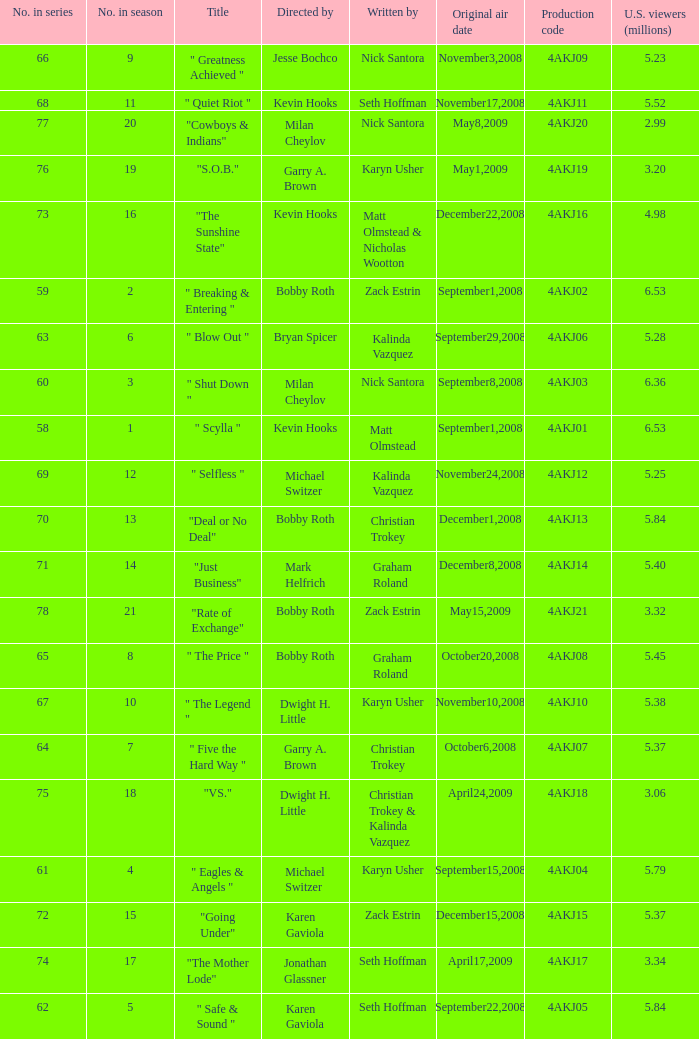Who directed the episode with production code 4akj01? Kevin Hooks. Could you help me parse every detail presented in this table? {'header': ['No. in series', 'No. in season', 'Title', 'Directed by', 'Written by', 'Original air date', 'Production code', 'U.S. viewers (millions)'], 'rows': [['66', '9', '" Greatness Achieved "', 'Jesse Bochco', 'Nick Santora', 'November3,2008', '4AKJ09', '5.23'], ['68', '11', '" Quiet Riot "', 'Kevin Hooks', 'Seth Hoffman', 'November17,2008', '4AKJ11', '5.52'], ['77', '20', '"Cowboys & Indians"', 'Milan Cheylov', 'Nick Santora', 'May8,2009', '4AKJ20', '2.99'], ['76', '19', '"S.O.B."', 'Garry A. Brown', 'Karyn Usher', 'May1,2009', '4AKJ19', '3.20'], ['73', '16', '"The Sunshine State"', 'Kevin Hooks', 'Matt Olmstead & Nicholas Wootton', 'December22,2008', '4AKJ16', '4.98'], ['59', '2', '" Breaking & Entering "', 'Bobby Roth', 'Zack Estrin', 'September1,2008', '4AKJ02', '6.53'], ['63', '6', '" Blow Out "', 'Bryan Spicer', 'Kalinda Vazquez', 'September29,2008', '4AKJ06', '5.28'], ['60', '3', '" Shut Down "', 'Milan Cheylov', 'Nick Santora', 'September8,2008', '4AKJ03', '6.36'], ['58', '1', '" Scylla "', 'Kevin Hooks', 'Matt Olmstead', 'September1,2008', '4AKJ01', '6.53'], ['69', '12', '" Selfless "', 'Michael Switzer', 'Kalinda Vazquez', 'November24,2008', '4AKJ12', '5.25'], ['70', '13', '"Deal or No Deal"', 'Bobby Roth', 'Christian Trokey', 'December1,2008', '4AKJ13', '5.84'], ['71', '14', '"Just Business"', 'Mark Helfrich', 'Graham Roland', 'December8,2008', '4AKJ14', '5.40'], ['78', '21', '"Rate of Exchange"', 'Bobby Roth', 'Zack Estrin', 'May15,2009', '4AKJ21', '3.32'], ['65', '8', '" The Price "', 'Bobby Roth', 'Graham Roland', 'October20,2008', '4AKJ08', '5.45'], ['67', '10', '" The Legend "', 'Dwight H. Little', 'Karyn Usher', 'November10,2008', '4AKJ10', '5.38'], ['64', '7', '" Five the Hard Way "', 'Garry A. Brown', 'Christian Trokey', 'October6,2008', '4AKJ07', '5.37'], ['75', '18', '"VS."', 'Dwight H. Little', 'Christian Trokey & Kalinda Vazquez', 'April24,2009', '4AKJ18', '3.06'], ['61', '4', '" Eagles & Angels "', 'Michael Switzer', 'Karyn Usher', 'September15,2008', '4AKJ04', '5.79'], ['72', '15', '"Going Under"', 'Karen Gaviola', 'Zack Estrin', 'December15,2008', '4AKJ15', '5.37'], ['74', '17', '"The Mother Lode"', 'Jonathan Glassner', 'Seth Hoffman', 'April17,2009', '4AKJ17', '3.34'], ['62', '5', '" Safe & Sound "', 'Karen Gaviola', 'Seth Hoffman', 'September22,2008', '4AKJ05', '5.84']]} 